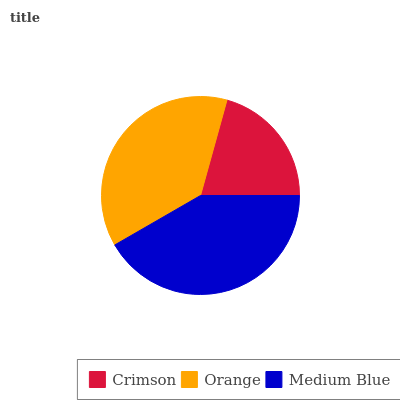Is Crimson the minimum?
Answer yes or no. Yes. Is Medium Blue the maximum?
Answer yes or no. Yes. Is Orange the minimum?
Answer yes or no. No. Is Orange the maximum?
Answer yes or no. No. Is Orange greater than Crimson?
Answer yes or no. Yes. Is Crimson less than Orange?
Answer yes or no. Yes. Is Crimson greater than Orange?
Answer yes or no. No. Is Orange less than Crimson?
Answer yes or no. No. Is Orange the high median?
Answer yes or no. Yes. Is Orange the low median?
Answer yes or no. Yes. Is Crimson the high median?
Answer yes or no. No. Is Crimson the low median?
Answer yes or no. No. 